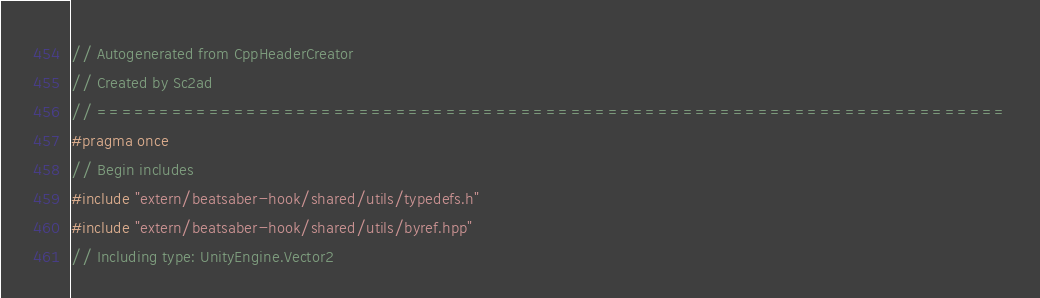<code> <loc_0><loc_0><loc_500><loc_500><_C++_>// Autogenerated from CppHeaderCreator
// Created by Sc2ad
// =========================================================================
#pragma once
// Begin includes
#include "extern/beatsaber-hook/shared/utils/typedefs.h"
#include "extern/beatsaber-hook/shared/utils/byref.hpp"
// Including type: UnityEngine.Vector2</code> 